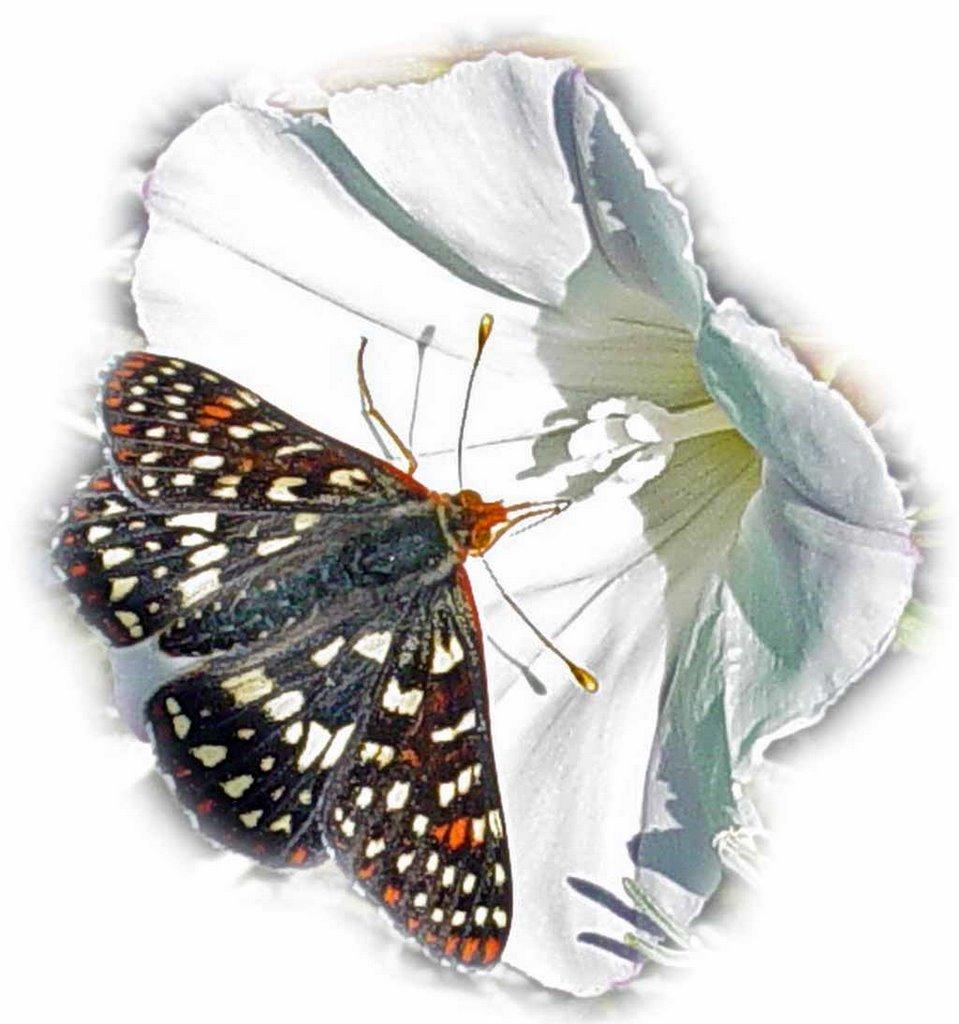What is the main subject of the image? There is a butterfly in the image. Can you describe the butterfly? The butterfly is colorful. Where is the butterfly located in the image? The butterfly is on a flower. What is the position of the flower in the image? The flower is in the center of the image. How many clocks are hanging on the wall behind the butterfly in the image? There are no clocks visible in the image; it features a butterfly on a flower. What type of bears can be seen interacting with the butterfly in the image? There are no bears present in the image; it features a butterfly on a flower. 